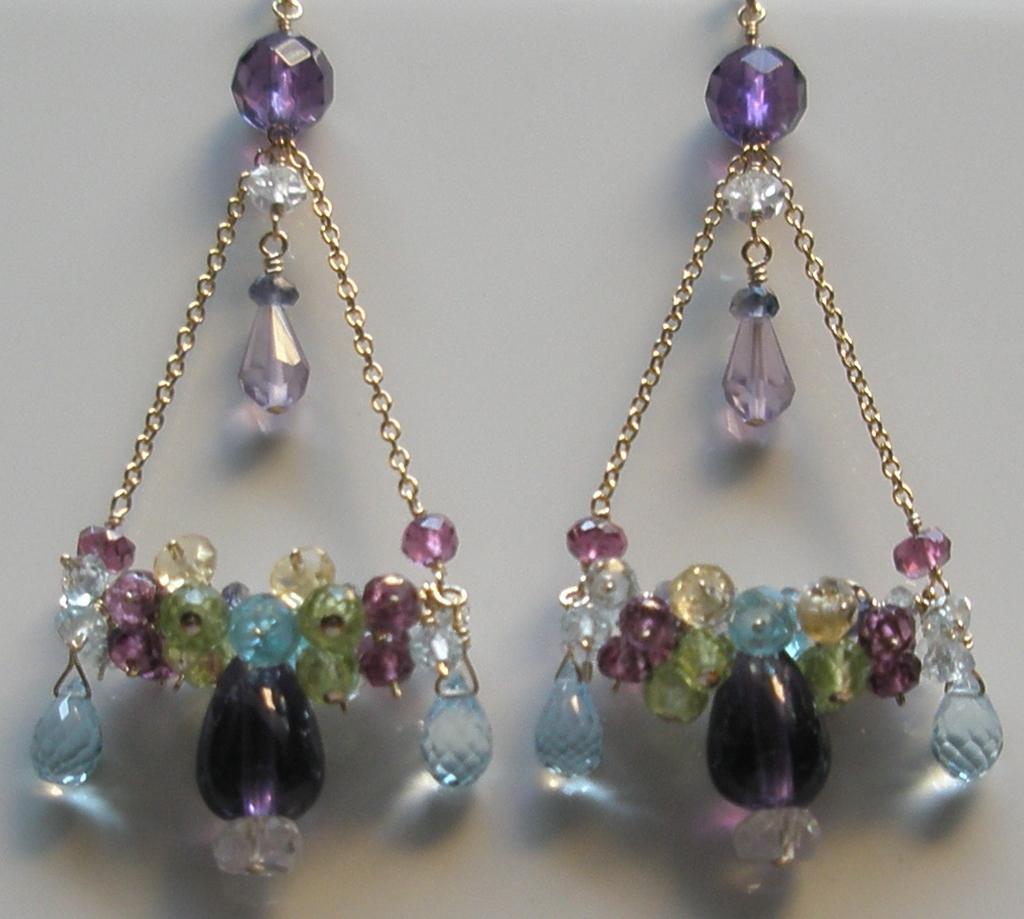Describe this image in one or two sentences. In this image I can see hangings with colorful beads and chains, these are looking like ear hangings. 